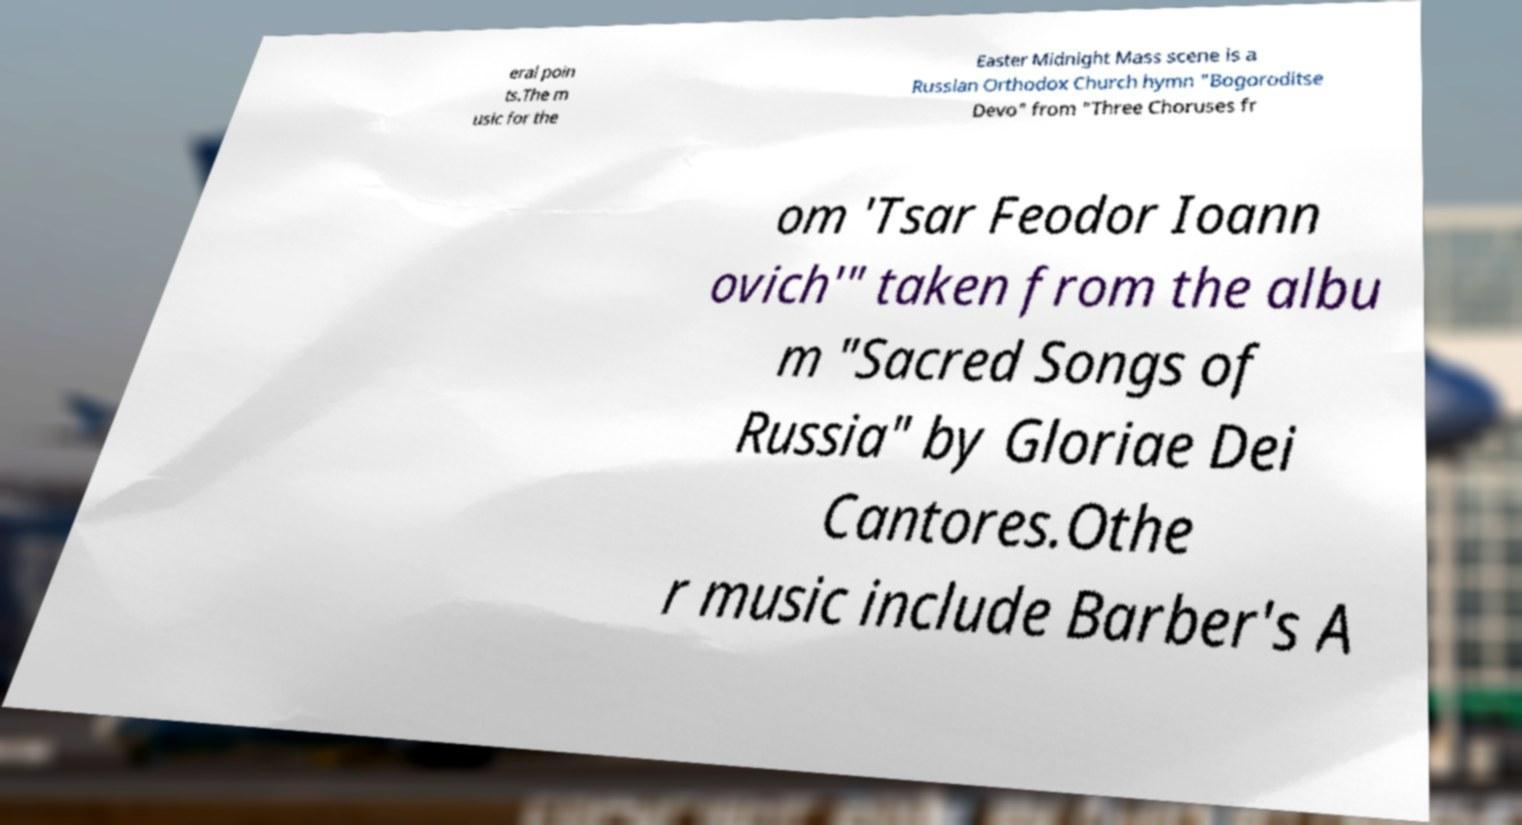Can you read and provide the text displayed in the image?This photo seems to have some interesting text. Can you extract and type it out for me? eral poin ts.The m usic for the Easter Midnight Mass scene is a Russian Orthodox Church hymn "Bogoroditse Devo" from "Three Choruses fr om 'Tsar Feodor Ioann ovich'" taken from the albu m "Sacred Songs of Russia" by Gloriae Dei Cantores.Othe r music include Barber's A 